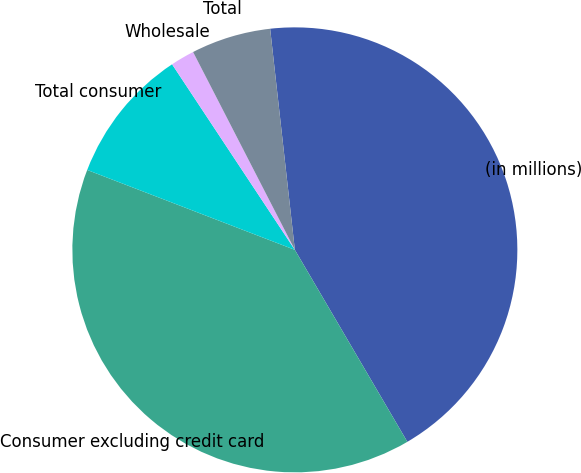<chart> <loc_0><loc_0><loc_500><loc_500><pie_chart><fcel>(in millions)<fcel>Consumer excluding credit card<fcel>Total consumer<fcel>Wholesale<fcel>Total<nl><fcel>43.33%<fcel>39.28%<fcel>9.85%<fcel>1.74%<fcel>5.79%<nl></chart> 